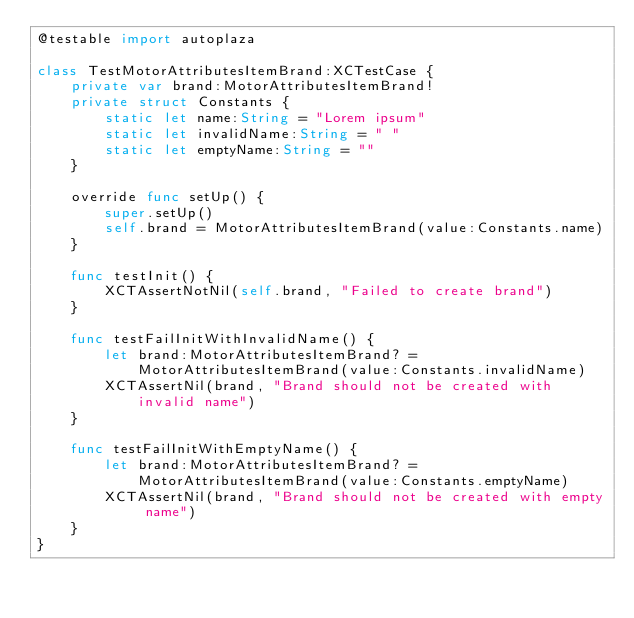<code> <loc_0><loc_0><loc_500><loc_500><_Swift_>@testable import autoplaza

class TestMotorAttributesItemBrand:XCTestCase {
    private var brand:MotorAttributesItemBrand!
    private struct Constants {
        static let name:String = "Lorem ipsum"
        static let invalidName:String = " "
        static let emptyName:String = ""
    }
    
    override func setUp() {
        super.setUp()
        self.brand = MotorAttributesItemBrand(value:Constants.name)
    }
    
    func testInit() {
        XCTAssertNotNil(self.brand, "Failed to create brand")
    }
    
    func testFailInitWithInvalidName() {
        let brand:MotorAttributesItemBrand? = MotorAttributesItemBrand(value:Constants.invalidName)
        XCTAssertNil(brand, "Brand should not be created with invalid name")
    }
    
    func testFailInitWithEmptyName() {
        let brand:MotorAttributesItemBrand? = MotorAttributesItemBrand(value:Constants.emptyName)
        XCTAssertNil(brand, "Brand should not be created with empty name")
    }
}
</code> 